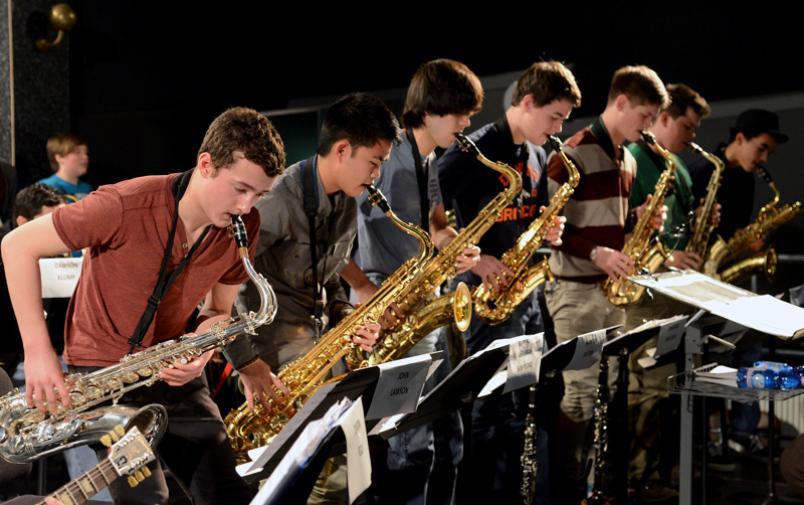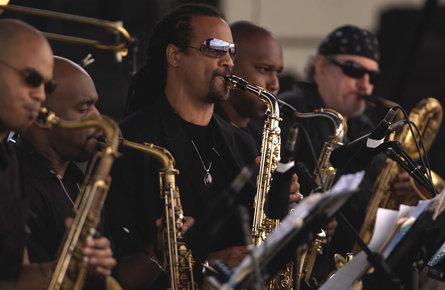The first image is the image on the left, the second image is the image on the right. Assess this claim about the two images: "All of the saxophone players are facing rightward and standing in a single row.". Correct or not? Answer yes or no. Yes. The first image is the image on the left, the second image is the image on the right. Analyze the images presented: Is the assertion "One of the musicians playing a saxophone depicted in the image on the right is a woman." valid? Answer yes or no. No. 